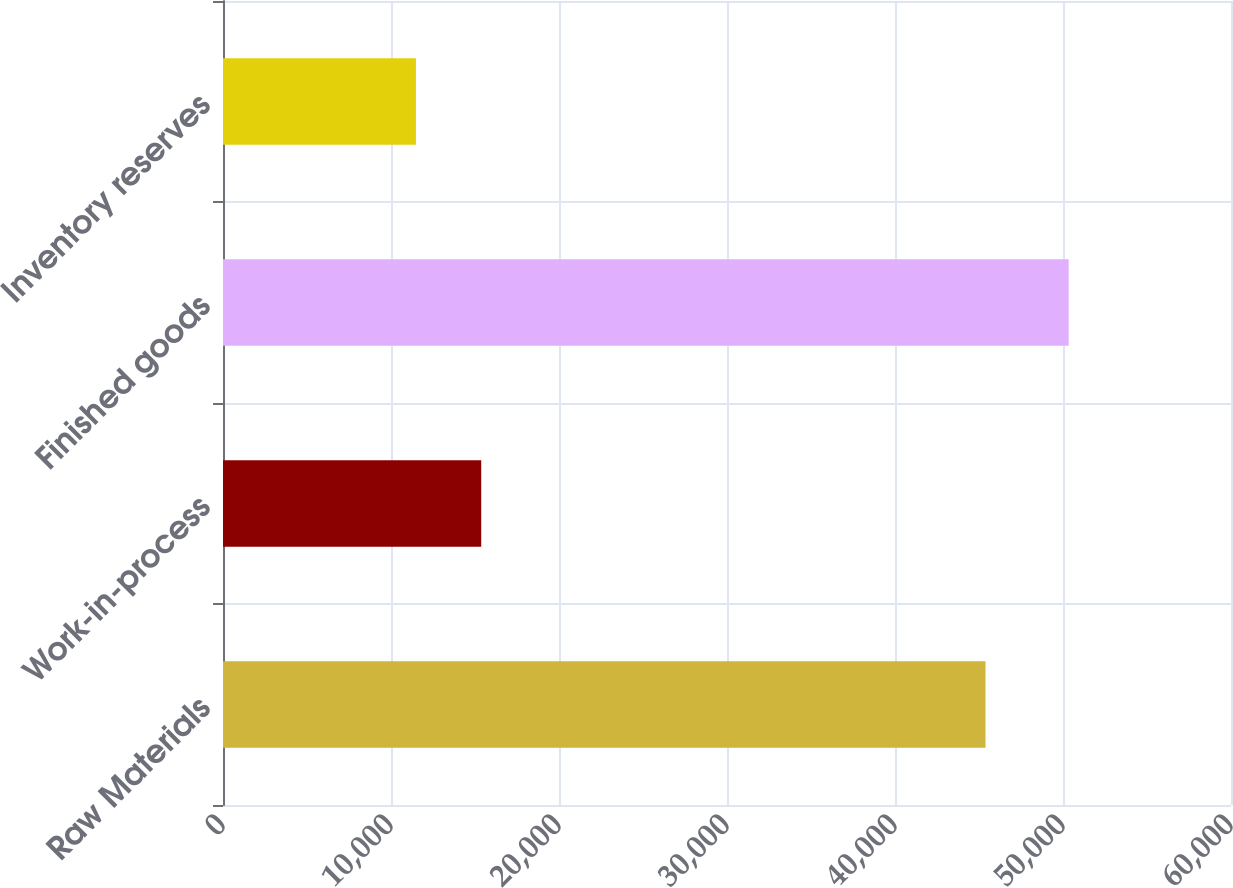Convert chart to OTSL. <chart><loc_0><loc_0><loc_500><loc_500><bar_chart><fcel>Raw Materials<fcel>Work-in-process<fcel>Finished goods<fcel>Inventory reserves<nl><fcel>45388<fcel>15370.5<fcel>50340<fcel>11485<nl></chart> 